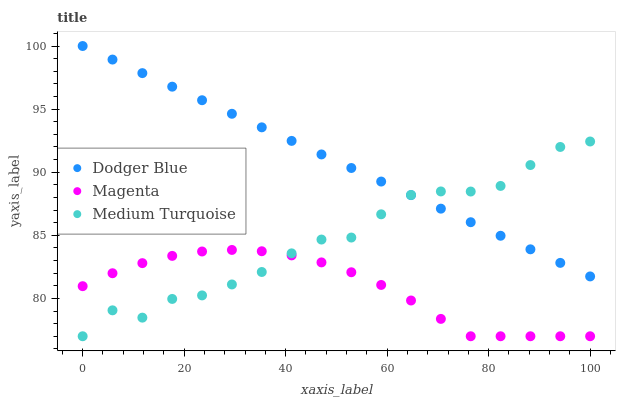Does Magenta have the minimum area under the curve?
Answer yes or no. Yes. Does Dodger Blue have the maximum area under the curve?
Answer yes or no. Yes. Does Medium Turquoise have the minimum area under the curve?
Answer yes or no. No. Does Medium Turquoise have the maximum area under the curve?
Answer yes or no. No. Is Dodger Blue the smoothest?
Answer yes or no. Yes. Is Medium Turquoise the roughest?
Answer yes or no. Yes. Is Medium Turquoise the smoothest?
Answer yes or no. No. Is Dodger Blue the roughest?
Answer yes or no. No. Does Magenta have the lowest value?
Answer yes or no. Yes. Does Dodger Blue have the lowest value?
Answer yes or no. No. Does Dodger Blue have the highest value?
Answer yes or no. Yes. Does Medium Turquoise have the highest value?
Answer yes or no. No. Is Magenta less than Dodger Blue?
Answer yes or no. Yes. Is Dodger Blue greater than Magenta?
Answer yes or no. Yes. Does Dodger Blue intersect Medium Turquoise?
Answer yes or no. Yes. Is Dodger Blue less than Medium Turquoise?
Answer yes or no. No. Is Dodger Blue greater than Medium Turquoise?
Answer yes or no. No. Does Magenta intersect Dodger Blue?
Answer yes or no. No. 